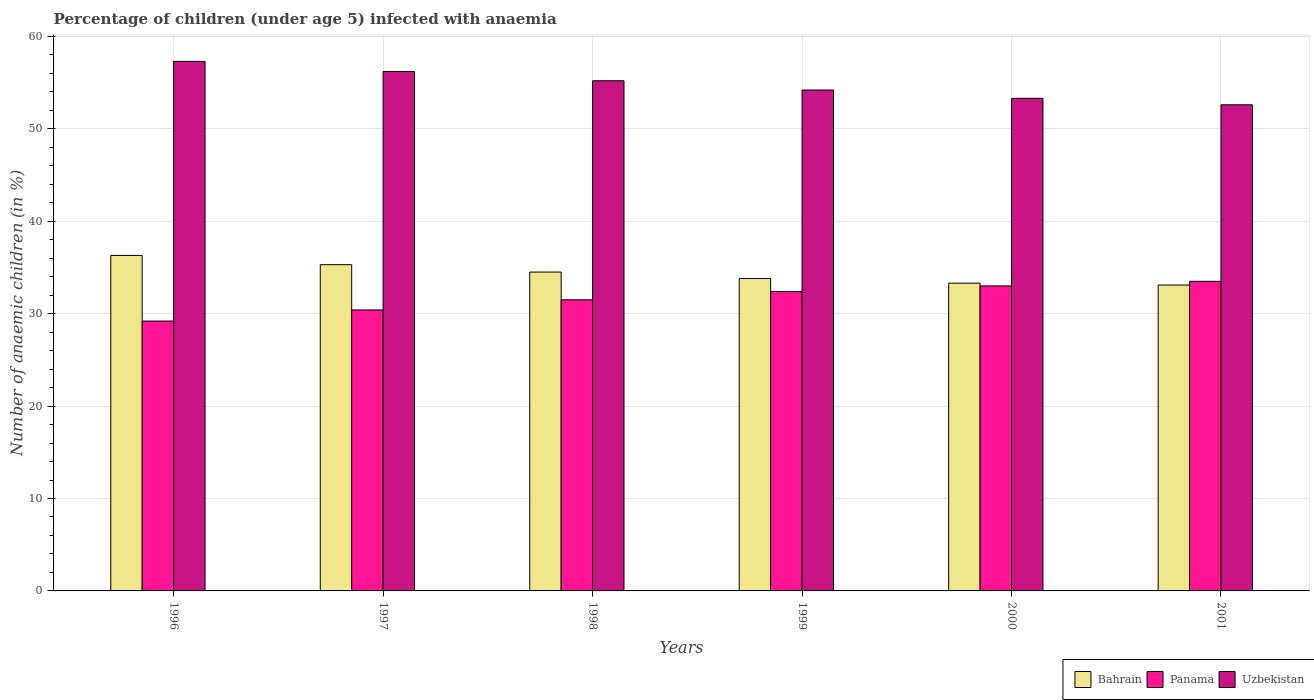Are the number of bars per tick equal to the number of legend labels?
Keep it short and to the point. Yes. Are the number of bars on each tick of the X-axis equal?
Ensure brevity in your answer.  Yes. How many bars are there on the 2nd tick from the left?
Your answer should be compact. 3. How many bars are there on the 4th tick from the right?
Offer a very short reply. 3. What is the percentage of children infected with anaemia in in Bahrain in 1996?
Your answer should be very brief. 36.3. Across all years, what is the maximum percentage of children infected with anaemia in in Panama?
Keep it short and to the point. 33.5. Across all years, what is the minimum percentage of children infected with anaemia in in Bahrain?
Your answer should be compact. 33.1. In which year was the percentage of children infected with anaemia in in Bahrain maximum?
Provide a short and direct response. 1996. In which year was the percentage of children infected with anaemia in in Bahrain minimum?
Make the answer very short. 2001. What is the total percentage of children infected with anaemia in in Uzbekistan in the graph?
Your answer should be very brief. 328.8. What is the difference between the percentage of children infected with anaemia in in Panama in 1997 and that in 1998?
Provide a short and direct response. -1.1. What is the difference between the percentage of children infected with anaemia in in Uzbekistan in 1996 and the percentage of children infected with anaemia in in Panama in 1999?
Ensure brevity in your answer.  24.9. What is the average percentage of children infected with anaemia in in Panama per year?
Ensure brevity in your answer.  31.67. In the year 1999, what is the difference between the percentage of children infected with anaemia in in Bahrain and percentage of children infected with anaemia in in Panama?
Give a very brief answer. 1.4. In how many years, is the percentage of children infected with anaemia in in Panama greater than 2 %?
Provide a short and direct response. 6. What is the ratio of the percentage of children infected with anaemia in in Uzbekistan in 1996 to that in 2000?
Ensure brevity in your answer.  1.08. Is the difference between the percentage of children infected with anaemia in in Bahrain in 1996 and 1999 greater than the difference between the percentage of children infected with anaemia in in Panama in 1996 and 1999?
Provide a succinct answer. Yes. What is the difference between the highest and the lowest percentage of children infected with anaemia in in Bahrain?
Give a very brief answer. 3.2. In how many years, is the percentage of children infected with anaemia in in Uzbekistan greater than the average percentage of children infected with anaemia in in Uzbekistan taken over all years?
Offer a very short reply. 3. Is the sum of the percentage of children infected with anaemia in in Panama in 1996 and 1998 greater than the maximum percentage of children infected with anaemia in in Uzbekistan across all years?
Ensure brevity in your answer.  Yes. What does the 2nd bar from the left in 1998 represents?
Offer a terse response. Panama. What does the 1st bar from the right in 1997 represents?
Ensure brevity in your answer.  Uzbekistan. How many bars are there?
Your answer should be compact. 18. Does the graph contain grids?
Provide a short and direct response. Yes. Where does the legend appear in the graph?
Your answer should be compact. Bottom right. How many legend labels are there?
Ensure brevity in your answer.  3. What is the title of the graph?
Make the answer very short. Percentage of children (under age 5) infected with anaemia. What is the label or title of the Y-axis?
Offer a very short reply. Number of anaemic children (in %). What is the Number of anaemic children (in %) of Bahrain in 1996?
Offer a terse response. 36.3. What is the Number of anaemic children (in %) of Panama in 1996?
Give a very brief answer. 29.2. What is the Number of anaemic children (in %) in Uzbekistan in 1996?
Provide a succinct answer. 57.3. What is the Number of anaemic children (in %) in Bahrain in 1997?
Offer a very short reply. 35.3. What is the Number of anaemic children (in %) in Panama in 1997?
Offer a very short reply. 30.4. What is the Number of anaemic children (in %) of Uzbekistan in 1997?
Provide a short and direct response. 56.2. What is the Number of anaemic children (in %) in Bahrain in 1998?
Keep it short and to the point. 34.5. What is the Number of anaemic children (in %) in Panama in 1998?
Give a very brief answer. 31.5. What is the Number of anaemic children (in %) of Uzbekistan in 1998?
Your answer should be very brief. 55.2. What is the Number of anaemic children (in %) in Bahrain in 1999?
Your answer should be very brief. 33.8. What is the Number of anaemic children (in %) of Panama in 1999?
Give a very brief answer. 32.4. What is the Number of anaemic children (in %) of Uzbekistan in 1999?
Provide a succinct answer. 54.2. What is the Number of anaemic children (in %) of Bahrain in 2000?
Ensure brevity in your answer.  33.3. What is the Number of anaemic children (in %) of Panama in 2000?
Keep it short and to the point. 33. What is the Number of anaemic children (in %) in Uzbekistan in 2000?
Your response must be concise. 53.3. What is the Number of anaemic children (in %) in Bahrain in 2001?
Give a very brief answer. 33.1. What is the Number of anaemic children (in %) of Panama in 2001?
Offer a very short reply. 33.5. What is the Number of anaemic children (in %) in Uzbekistan in 2001?
Keep it short and to the point. 52.6. Across all years, what is the maximum Number of anaemic children (in %) of Bahrain?
Your answer should be compact. 36.3. Across all years, what is the maximum Number of anaemic children (in %) in Panama?
Offer a very short reply. 33.5. Across all years, what is the maximum Number of anaemic children (in %) in Uzbekistan?
Your answer should be compact. 57.3. Across all years, what is the minimum Number of anaemic children (in %) of Bahrain?
Provide a short and direct response. 33.1. Across all years, what is the minimum Number of anaemic children (in %) of Panama?
Your answer should be compact. 29.2. Across all years, what is the minimum Number of anaemic children (in %) of Uzbekistan?
Make the answer very short. 52.6. What is the total Number of anaemic children (in %) of Bahrain in the graph?
Your response must be concise. 206.3. What is the total Number of anaemic children (in %) in Panama in the graph?
Make the answer very short. 190. What is the total Number of anaemic children (in %) in Uzbekistan in the graph?
Give a very brief answer. 328.8. What is the difference between the Number of anaemic children (in %) in Uzbekistan in 1996 and that in 1997?
Offer a very short reply. 1.1. What is the difference between the Number of anaemic children (in %) in Bahrain in 1996 and that in 1998?
Give a very brief answer. 1.8. What is the difference between the Number of anaemic children (in %) in Uzbekistan in 1996 and that in 1998?
Your answer should be compact. 2.1. What is the difference between the Number of anaemic children (in %) of Uzbekistan in 1996 and that in 1999?
Your answer should be compact. 3.1. What is the difference between the Number of anaemic children (in %) in Bahrain in 1996 and that in 2000?
Offer a terse response. 3. What is the difference between the Number of anaemic children (in %) in Uzbekistan in 1996 and that in 2000?
Offer a very short reply. 4. What is the difference between the Number of anaemic children (in %) in Panama in 1996 and that in 2001?
Offer a very short reply. -4.3. What is the difference between the Number of anaemic children (in %) in Uzbekistan in 1996 and that in 2001?
Offer a terse response. 4.7. What is the difference between the Number of anaemic children (in %) in Panama in 1997 and that in 1998?
Offer a terse response. -1.1. What is the difference between the Number of anaemic children (in %) of Bahrain in 1997 and that in 1999?
Your response must be concise. 1.5. What is the difference between the Number of anaemic children (in %) in Bahrain in 1997 and that in 2000?
Keep it short and to the point. 2. What is the difference between the Number of anaemic children (in %) of Uzbekistan in 1997 and that in 2000?
Your response must be concise. 2.9. What is the difference between the Number of anaemic children (in %) in Bahrain in 1997 and that in 2001?
Offer a very short reply. 2.2. What is the difference between the Number of anaemic children (in %) in Uzbekistan in 1997 and that in 2001?
Offer a very short reply. 3.6. What is the difference between the Number of anaemic children (in %) in Bahrain in 1998 and that in 1999?
Provide a short and direct response. 0.7. What is the difference between the Number of anaemic children (in %) in Bahrain in 1998 and that in 2000?
Your response must be concise. 1.2. What is the difference between the Number of anaemic children (in %) in Panama in 1998 and that in 2000?
Your answer should be very brief. -1.5. What is the difference between the Number of anaemic children (in %) of Uzbekistan in 1998 and that in 2001?
Offer a terse response. 2.6. What is the difference between the Number of anaemic children (in %) of Panama in 1999 and that in 2000?
Ensure brevity in your answer.  -0.6. What is the difference between the Number of anaemic children (in %) of Bahrain in 1999 and that in 2001?
Give a very brief answer. 0.7. What is the difference between the Number of anaemic children (in %) in Panama in 1999 and that in 2001?
Your response must be concise. -1.1. What is the difference between the Number of anaemic children (in %) of Uzbekistan in 2000 and that in 2001?
Your answer should be very brief. 0.7. What is the difference between the Number of anaemic children (in %) of Bahrain in 1996 and the Number of anaemic children (in %) of Panama in 1997?
Offer a very short reply. 5.9. What is the difference between the Number of anaemic children (in %) of Bahrain in 1996 and the Number of anaemic children (in %) of Uzbekistan in 1997?
Ensure brevity in your answer.  -19.9. What is the difference between the Number of anaemic children (in %) of Bahrain in 1996 and the Number of anaemic children (in %) of Panama in 1998?
Keep it short and to the point. 4.8. What is the difference between the Number of anaemic children (in %) of Bahrain in 1996 and the Number of anaemic children (in %) of Uzbekistan in 1998?
Your answer should be compact. -18.9. What is the difference between the Number of anaemic children (in %) of Bahrain in 1996 and the Number of anaemic children (in %) of Panama in 1999?
Keep it short and to the point. 3.9. What is the difference between the Number of anaemic children (in %) of Bahrain in 1996 and the Number of anaemic children (in %) of Uzbekistan in 1999?
Your answer should be compact. -17.9. What is the difference between the Number of anaemic children (in %) in Panama in 1996 and the Number of anaemic children (in %) in Uzbekistan in 1999?
Your answer should be very brief. -25. What is the difference between the Number of anaemic children (in %) of Panama in 1996 and the Number of anaemic children (in %) of Uzbekistan in 2000?
Give a very brief answer. -24.1. What is the difference between the Number of anaemic children (in %) in Bahrain in 1996 and the Number of anaemic children (in %) in Uzbekistan in 2001?
Your response must be concise. -16.3. What is the difference between the Number of anaemic children (in %) in Panama in 1996 and the Number of anaemic children (in %) in Uzbekistan in 2001?
Give a very brief answer. -23.4. What is the difference between the Number of anaemic children (in %) of Bahrain in 1997 and the Number of anaemic children (in %) of Uzbekistan in 1998?
Give a very brief answer. -19.9. What is the difference between the Number of anaemic children (in %) of Panama in 1997 and the Number of anaemic children (in %) of Uzbekistan in 1998?
Make the answer very short. -24.8. What is the difference between the Number of anaemic children (in %) of Bahrain in 1997 and the Number of anaemic children (in %) of Panama in 1999?
Offer a terse response. 2.9. What is the difference between the Number of anaemic children (in %) in Bahrain in 1997 and the Number of anaemic children (in %) in Uzbekistan in 1999?
Give a very brief answer. -18.9. What is the difference between the Number of anaemic children (in %) of Panama in 1997 and the Number of anaemic children (in %) of Uzbekistan in 1999?
Your answer should be very brief. -23.8. What is the difference between the Number of anaemic children (in %) in Bahrain in 1997 and the Number of anaemic children (in %) in Panama in 2000?
Your answer should be very brief. 2.3. What is the difference between the Number of anaemic children (in %) of Panama in 1997 and the Number of anaemic children (in %) of Uzbekistan in 2000?
Provide a short and direct response. -22.9. What is the difference between the Number of anaemic children (in %) in Bahrain in 1997 and the Number of anaemic children (in %) in Uzbekistan in 2001?
Your answer should be very brief. -17.3. What is the difference between the Number of anaemic children (in %) of Panama in 1997 and the Number of anaemic children (in %) of Uzbekistan in 2001?
Give a very brief answer. -22.2. What is the difference between the Number of anaemic children (in %) in Bahrain in 1998 and the Number of anaemic children (in %) in Panama in 1999?
Give a very brief answer. 2.1. What is the difference between the Number of anaemic children (in %) in Bahrain in 1998 and the Number of anaemic children (in %) in Uzbekistan in 1999?
Your answer should be very brief. -19.7. What is the difference between the Number of anaemic children (in %) in Panama in 1998 and the Number of anaemic children (in %) in Uzbekistan in 1999?
Ensure brevity in your answer.  -22.7. What is the difference between the Number of anaemic children (in %) of Bahrain in 1998 and the Number of anaemic children (in %) of Panama in 2000?
Offer a very short reply. 1.5. What is the difference between the Number of anaemic children (in %) of Bahrain in 1998 and the Number of anaemic children (in %) of Uzbekistan in 2000?
Keep it short and to the point. -18.8. What is the difference between the Number of anaemic children (in %) of Panama in 1998 and the Number of anaemic children (in %) of Uzbekistan in 2000?
Your response must be concise. -21.8. What is the difference between the Number of anaemic children (in %) in Bahrain in 1998 and the Number of anaemic children (in %) in Panama in 2001?
Keep it short and to the point. 1. What is the difference between the Number of anaemic children (in %) in Bahrain in 1998 and the Number of anaemic children (in %) in Uzbekistan in 2001?
Keep it short and to the point. -18.1. What is the difference between the Number of anaemic children (in %) in Panama in 1998 and the Number of anaemic children (in %) in Uzbekistan in 2001?
Offer a terse response. -21.1. What is the difference between the Number of anaemic children (in %) of Bahrain in 1999 and the Number of anaemic children (in %) of Uzbekistan in 2000?
Give a very brief answer. -19.5. What is the difference between the Number of anaemic children (in %) in Panama in 1999 and the Number of anaemic children (in %) in Uzbekistan in 2000?
Keep it short and to the point. -20.9. What is the difference between the Number of anaemic children (in %) of Bahrain in 1999 and the Number of anaemic children (in %) of Panama in 2001?
Ensure brevity in your answer.  0.3. What is the difference between the Number of anaemic children (in %) of Bahrain in 1999 and the Number of anaemic children (in %) of Uzbekistan in 2001?
Your answer should be compact. -18.8. What is the difference between the Number of anaemic children (in %) of Panama in 1999 and the Number of anaemic children (in %) of Uzbekistan in 2001?
Your answer should be compact. -20.2. What is the difference between the Number of anaemic children (in %) of Bahrain in 2000 and the Number of anaemic children (in %) of Panama in 2001?
Offer a terse response. -0.2. What is the difference between the Number of anaemic children (in %) of Bahrain in 2000 and the Number of anaemic children (in %) of Uzbekistan in 2001?
Make the answer very short. -19.3. What is the difference between the Number of anaemic children (in %) in Panama in 2000 and the Number of anaemic children (in %) in Uzbekistan in 2001?
Offer a terse response. -19.6. What is the average Number of anaemic children (in %) of Bahrain per year?
Keep it short and to the point. 34.38. What is the average Number of anaemic children (in %) of Panama per year?
Give a very brief answer. 31.67. What is the average Number of anaemic children (in %) of Uzbekistan per year?
Ensure brevity in your answer.  54.8. In the year 1996, what is the difference between the Number of anaemic children (in %) in Panama and Number of anaemic children (in %) in Uzbekistan?
Ensure brevity in your answer.  -28.1. In the year 1997, what is the difference between the Number of anaemic children (in %) in Bahrain and Number of anaemic children (in %) in Panama?
Offer a terse response. 4.9. In the year 1997, what is the difference between the Number of anaemic children (in %) of Bahrain and Number of anaemic children (in %) of Uzbekistan?
Ensure brevity in your answer.  -20.9. In the year 1997, what is the difference between the Number of anaemic children (in %) of Panama and Number of anaemic children (in %) of Uzbekistan?
Your answer should be very brief. -25.8. In the year 1998, what is the difference between the Number of anaemic children (in %) in Bahrain and Number of anaemic children (in %) in Uzbekistan?
Your response must be concise. -20.7. In the year 1998, what is the difference between the Number of anaemic children (in %) of Panama and Number of anaemic children (in %) of Uzbekistan?
Ensure brevity in your answer.  -23.7. In the year 1999, what is the difference between the Number of anaemic children (in %) in Bahrain and Number of anaemic children (in %) in Uzbekistan?
Make the answer very short. -20.4. In the year 1999, what is the difference between the Number of anaemic children (in %) of Panama and Number of anaemic children (in %) of Uzbekistan?
Your answer should be very brief. -21.8. In the year 2000, what is the difference between the Number of anaemic children (in %) in Bahrain and Number of anaemic children (in %) in Panama?
Ensure brevity in your answer.  0.3. In the year 2000, what is the difference between the Number of anaemic children (in %) in Bahrain and Number of anaemic children (in %) in Uzbekistan?
Your answer should be compact. -20. In the year 2000, what is the difference between the Number of anaemic children (in %) in Panama and Number of anaemic children (in %) in Uzbekistan?
Offer a very short reply. -20.3. In the year 2001, what is the difference between the Number of anaemic children (in %) in Bahrain and Number of anaemic children (in %) in Panama?
Provide a succinct answer. -0.4. In the year 2001, what is the difference between the Number of anaemic children (in %) of Bahrain and Number of anaemic children (in %) of Uzbekistan?
Offer a terse response. -19.5. In the year 2001, what is the difference between the Number of anaemic children (in %) of Panama and Number of anaemic children (in %) of Uzbekistan?
Provide a succinct answer. -19.1. What is the ratio of the Number of anaemic children (in %) of Bahrain in 1996 to that in 1997?
Your response must be concise. 1.03. What is the ratio of the Number of anaemic children (in %) in Panama in 1996 to that in 1997?
Offer a terse response. 0.96. What is the ratio of the Number of anaemic children (in %) in Uzbekistan in 1996 to that in 1997?
Offer a very short reply. 1.02. What is the ratio of the Number of anaemic children (in %) of Bahrain in 1996 to that in 1998?
Offer a very short reply. 1.05. What is the ratio of the Number of anaemic children (in %) of Panama in 1996 to that in 1998?
Your answer should be very brief. 0.93. What is the ratio of the Number of anaemic children (in %) in Uzbekistan in 1996 to that in 1998?
Your answer should be compact. 1.04. What is the ratio of the Number of anaemic children (in %) of Bahrain in 1996 to that in 1999?
Your response must be concise. 1.07. What is the ratio of the Number of anaemic children (in %) of Panama in 1996 to that in 1999?
Your answer should be compact. 0.9. What is the ratio of the Number of anaemic children (in %) of Uzbekistan in 1996 to that in 1999?
Provide a succinct answer. 1.06. What is the ratio of the Number of anaemic children (in %) in Bahrain in 1996 to that in 2000?
Provide a succinct answer. 1.09. What is the ratio of the Number of anaemic children (in %) of Panama in 1996 to that in 2000?
Make the answer very short. 0.88. What is the ratio of the Number of anaemic children (in %) of Uzbekistan in 1996 to that in 2000?
Give a very brief answer. 1.07. What is the ratio of the Number of anaemic children (in %) of Bahrain in 1996 to that in 2001?
Your answer should be very brief. 1.1. What is the ratio of the Number of anaemic children (in %) in Panama in 1996 to that in 2001?
Give a very brief answer. 0.87. What is the ratio of the Number of anaemic children (in %) of Uzbekistan in 1996 to that in 2001?
Offer a terse response. 1.09. What is the ratio of the Number of anaemic children (in %) in Bahrain in 1997 to that in 1998?
Offer a very short reply. 1.02. What is the ratio of the Number of anaemic children (in %) in Panama in 1997 to that in 1998?
Your answer should be compact. 0.97. What is the ratio of the Number of anaemic children (in %) in Uzbekistan in 1997 to that in 1998?
Provide a succinct answer. 1.02. What is the ratio of the Number of anaemic children (in %) in Bahrain in 1997 to that in 1999?
Provide a short and direct response. 1.04. What is the ratio of the Number of anaemic children (in %) in Panama in 1997 to that in 1999?
Your response must be concise. 0.94. What is the ratio of the Number of anaemic children (in %) in Uzbekistan in 1997 to that in 1999?
Provide a short and direct response. 1.04. What is the ratio of the Number of anaemic children (in %) of Bahrain in 1997 to that in 2000?
Provide a succinct answer. 1.06. What is the ratio of the Number of anaemic children (in %) in Panama in 1997 to that in 2000?
Give a very brief answer. 0.92. What is the ratio of the Number of anaemic children (in %) in Uzbekistan in 1997 to that in 2000?
Offer a very short reply. 1.05. What is the ratio of the Number of anaemic children (in %) in Bahrain in 1997 to that in 2001?
Make the answer very short. 1.07. What is the ratio of the Number of anaemic children (in %) in Panama in 1997 to that in 2001?
Ensure brevity in your answer.  0.91. What is the ratio of the Number of anaemic children (in %) in Uzbekistan in 1997 to that in 2001?
Offer a very short reply. 1.07. What is the ratio of the Number of anaemic children (in %) of Bahrain in 1998 to that in 1999?
Your answer should be very brief. 1.02. What is the ratio of the Number of anaemic children (in %) in Panama in 1998 to that in 1999?
Keep it short and to the point. 0.97. What is the ratio of the Number of anaemic children (in %) of Uzbekistan in 1998 to that in 1999?
Ensure brevity in your answer.  1.02. What is the ratio of the Number of anaemic children (in %) in Bahrain in 1998 to that in 2000?
Your answer should be very brief. 1.04. What is the ratio of the Number of anaemic children (in %) in Panama in 1998 to that in 2000?
Keep it short and to the point. 0.95. What is the ratio of the Number of anaemic children (in %) of Uzbekistan in 1998 to that in 2000?
Make the answer very short. 1.04. What is the ratio of the Number of anaemic children (in %) of Bahrain in 1998 to that in 2001?
Your answer should be very brief. 1.04. What is the ratio of the Number of anaemic children (in %) in Panama in 1998 to that in 2001?
Offer a terse response. 0.94. What is the ratio of the Number of anaemic children (in %) of Uzbekistan in 1998 to that in 2001?
Keep it short and to the point. 1.05. What is the ratio of the Number of anaemic children (in %) of Bahrain in 1999 to that in 2000?
Give a very brief answer. 1.01. What is the ratio of the Number of anaemic children (in %) in Panama in 1999 to that in 2000?
Offer a very short reply. 0.98. What is the ratio of the Number of anaemic children (in %) in Uzbekistan in 1999 to that in 2000?
Provide a succinct answer. 1.02. What is the ratio of the Number of anaemic children (in %) in Bahrain in 1999 to that in 2001?
Make the answer very short. 1.02. What is the ratio of the Number of anaemic children (in %) of Panama in 1999 to that in 2001?
Your answer should be compact. 0.97. What is the ratio of the Number of anaemic children (in %) in Uzbekistan in 1999 to that in 2001?
Your response must be concise. 1.03. What is the ratio of the Number of anaemic children (in %) of Bahrain in 2000 to that in 2001?
Offer a terse response. 1.01. What is the ratio of the Number of anaemic children (in %) in Panama in 2000 to that in 2001?
Give a very brief answer. 0.99. What is the ratio of the Number of anaemic children (in %) in Uzbekistan in 2000 to that in 2001?
Your answer should be very brief. 1.01. What is the difference between the highest and the second highest Number of anaemic children (in %) in Bahrain?
Keep it short and to the point. 1. What is the difference between the highest and the second highest Number of anaemic children (in %) in Panama?
Offer a terse response. 0.5. What is the difference between the highest and the second highest Number of anaemic children (in %) in Uzbekistan?
Offer a very short reply. 1.1. What is the difference between the highest and the lowest Number of anaemic children (in %) of Panama?
Keep it short and to the point. 4.3. What is the difference between the highest and the lowest Number of anaemic children (in %) of Uzbekistan?
Offer a very short reply. 4.7. 